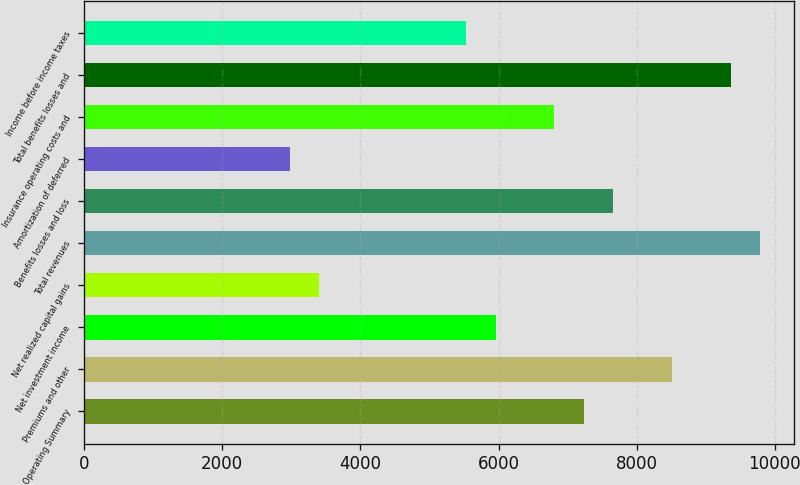<chart> <loc_0><loc_0><loc_500><loc_500><bar_chart><fcel>Operating Summary<fcel>Premiums and other<fcel>Net investment income<fcel>Net realized capital gains<fcel>Total revenues<fcel>Benefits losses and loss<fcel>Amortization of deferred<fcel>Insurance operating costs and<fcel>Total benefits losses and<fcel>Income before income taxes<nl><fcel>7233.08<fcel>8509.4<fcel>5956.76<fcel>3404.12<fcel>9785.72<fcel>7658.52<fcel>2978.68<fcel>6807.64<fcel>9360.28<fcel>5531.32<nl></chart> 